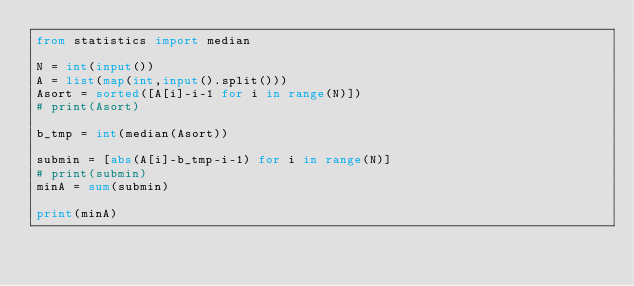Convert code to text. <code><loc_0><loc_0><loc_500><loc_500><_Python_>from statistics import median

N = int(input())
A = list(map(int,input().split()))
Asort = sorted([A[i]-i-1 for i in range(N)])
# print(Asort)

b_tmp = int(median(Asort))

submin = [abs(A[i]-b_tmp-i-1) for i in range(N)]
# print(submin)
minA = sum(submin)

print(minA)</code> 